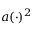Convert formula to latex. <formula><loc_0><loc_0><loc_500><loc_500>a ( \cdot ) ^ { 2 }</formula> 